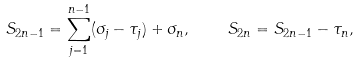Convert formula to latex. <formula><loc_0><loc_0><loc_500><loc_500>S _ { 2 n - 1 } = \sum _ { j = 1 } ^ { n - 1 } ( \sigma _ { j } - \tau _ { j } ) + \sigma _ { n } , \quad S _ { 2 n } = S _ { 2 n - 1 } - \tau _ { n } ,</formula> 